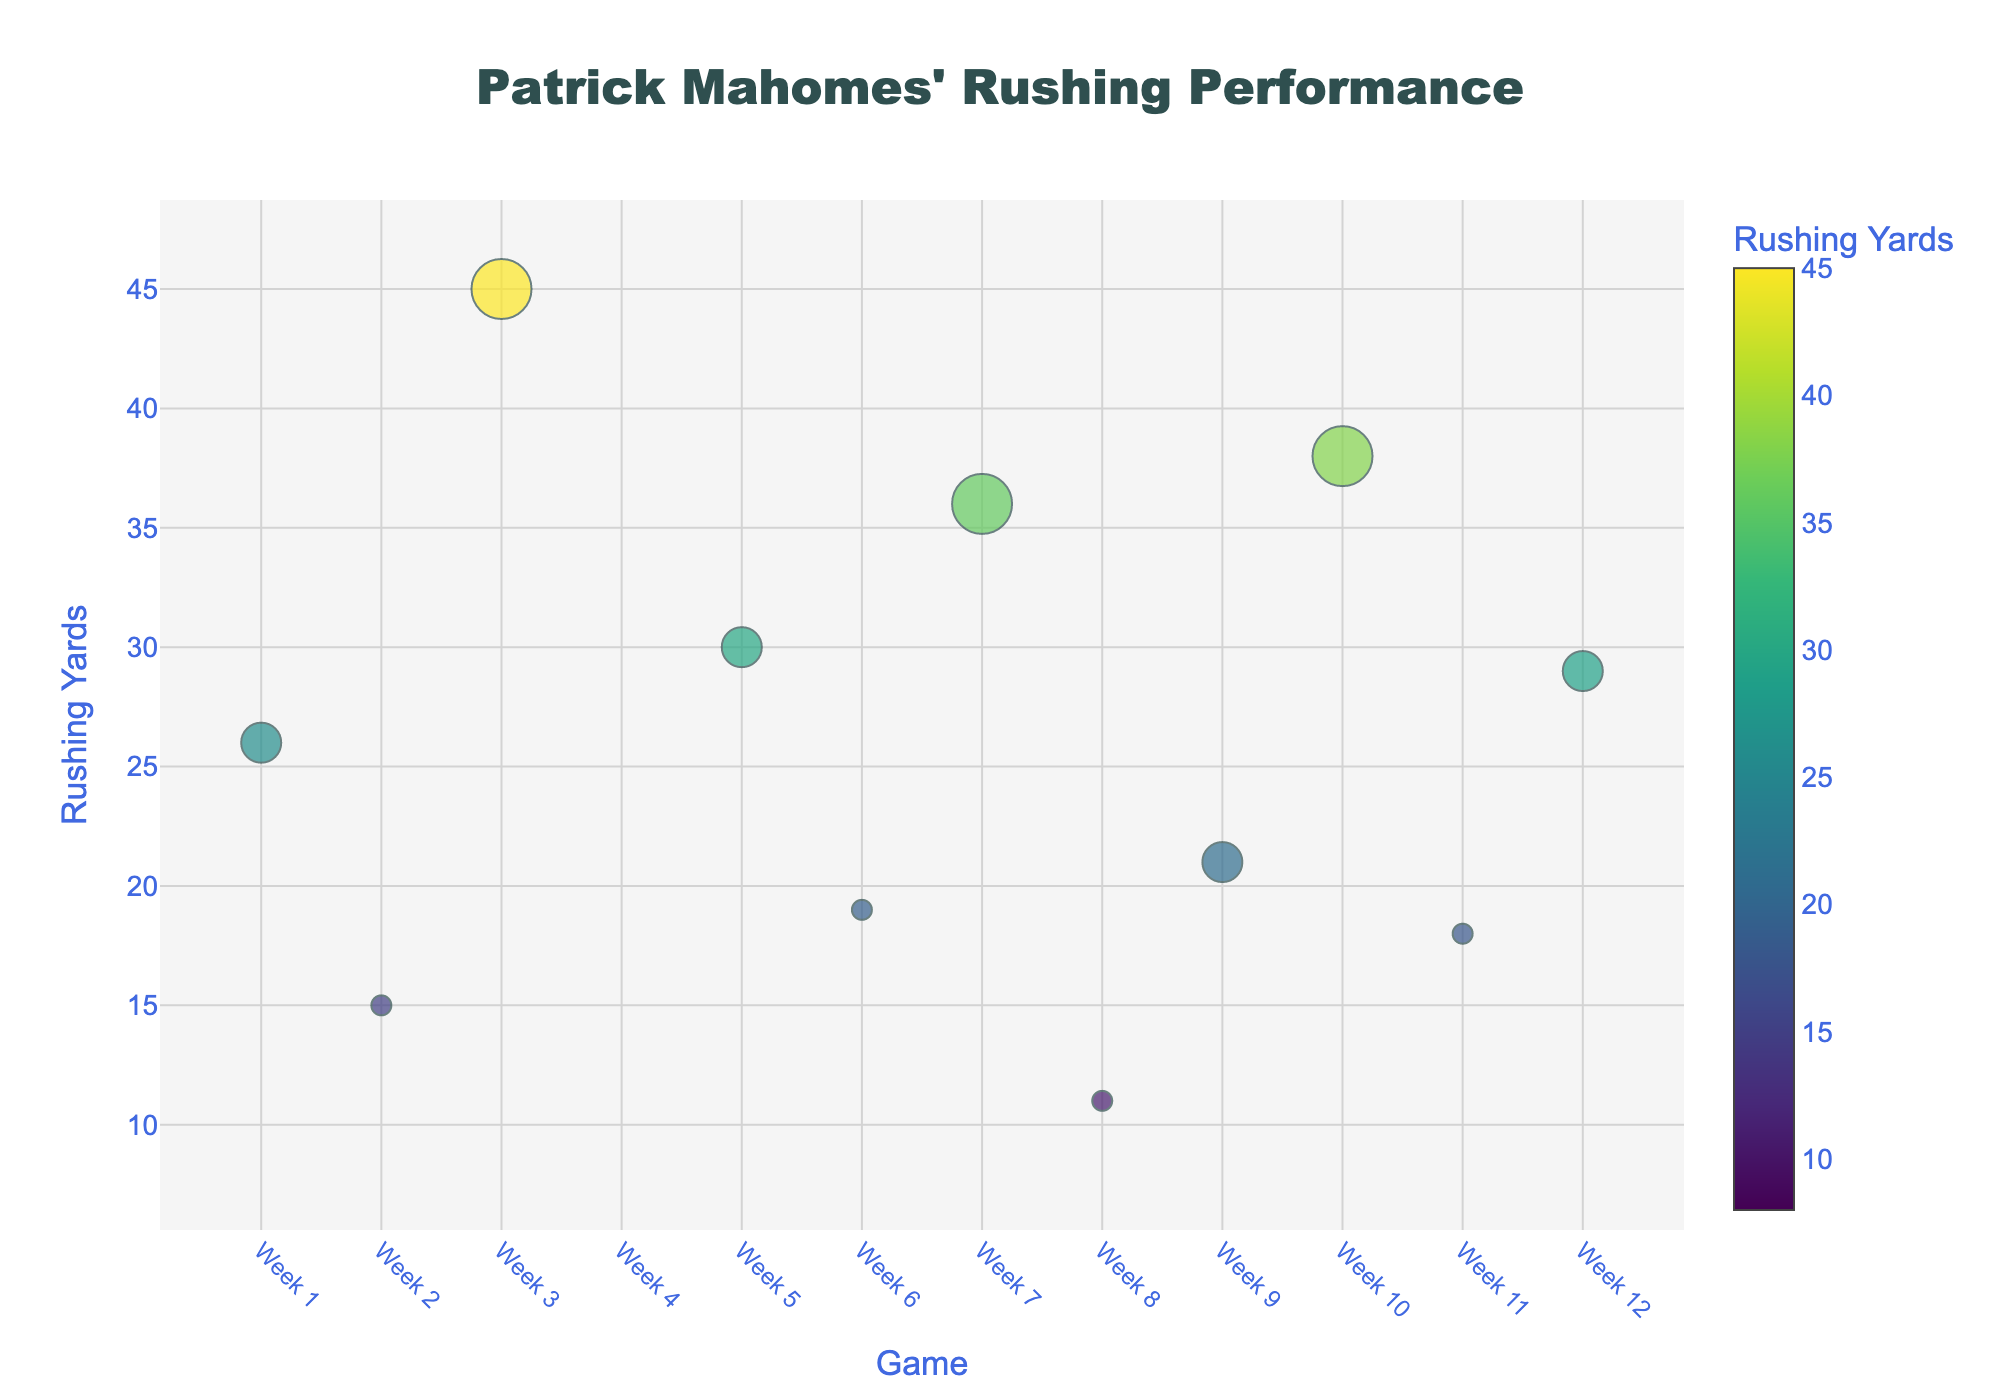What's the title of the plot? The title of the plot is prominently displayed at the top centre of the figure and is written in a large, dark slate grey font.
Answer: Patrick Mahomes' Rushing Performance How many games did Mahomes rush for more than 30 yards? Look at the 'Rushing Yards' axis and count the number of bubbles positioned above the 30-yard mark.
Answer: 4 Which game had the highest rushing yards, and how many first downs were converted in that game? Identify the bubble positioned highest on the 'Rushing Yards' axis, hover to see the game and first downs details.
Answer: Week 3, 3 first downs What is the color used for the lowest rushing yards and what does that represent? Check the color gradient provided in the figure legend and match the lightest color to the corresponding yardage.
Answer: Light yellow, representing 8 rushing yards Compare the size of the bubbles in Week 5 and Week 7. Which game had more first down conversions, and by how much? Compare the sizes of the bubbles for Week 5 and Week 7 by their visual appearance or by hovering over them to see the exact values.
Answer: Week 7, by 1 first down conversion What is the average number of first down conversions across all games? Sum the first down values from each game and divide by the total number of games. Calculations: (2+1+3+0+2+1+3+1+2+3+1+2) / 12 = 21 / 12
Answer: 1.75 Which game had the smallest bubble, and what was the rushing yardage in that game? Find the smallest bubble by visual inspection and then hover over it for details.
Answer: Week 4, 8 rushing yards How did Mahomes perform in terms of rushing yards against the Buffalo Bills compared to the Green Bay Packers? Compare the 'Rushing Yards' values for the games against the Buffalo Bills and Green Bay Packers seen on the Y-axis.
Answer: More against Buffalo Bills What color represents the rushing yards Mahomes achieved in Week 10? Hover over the Week 10 bubble to see the rushing yards and then match it with the color in the color bar.
Answer: Light green Looking at the bubble sizes, how many games did Mahomes convert exactly 2 first downs? Check the size of the bubbles and count the number of bubbles corresponding to 2 first downs.
Answer: 5 